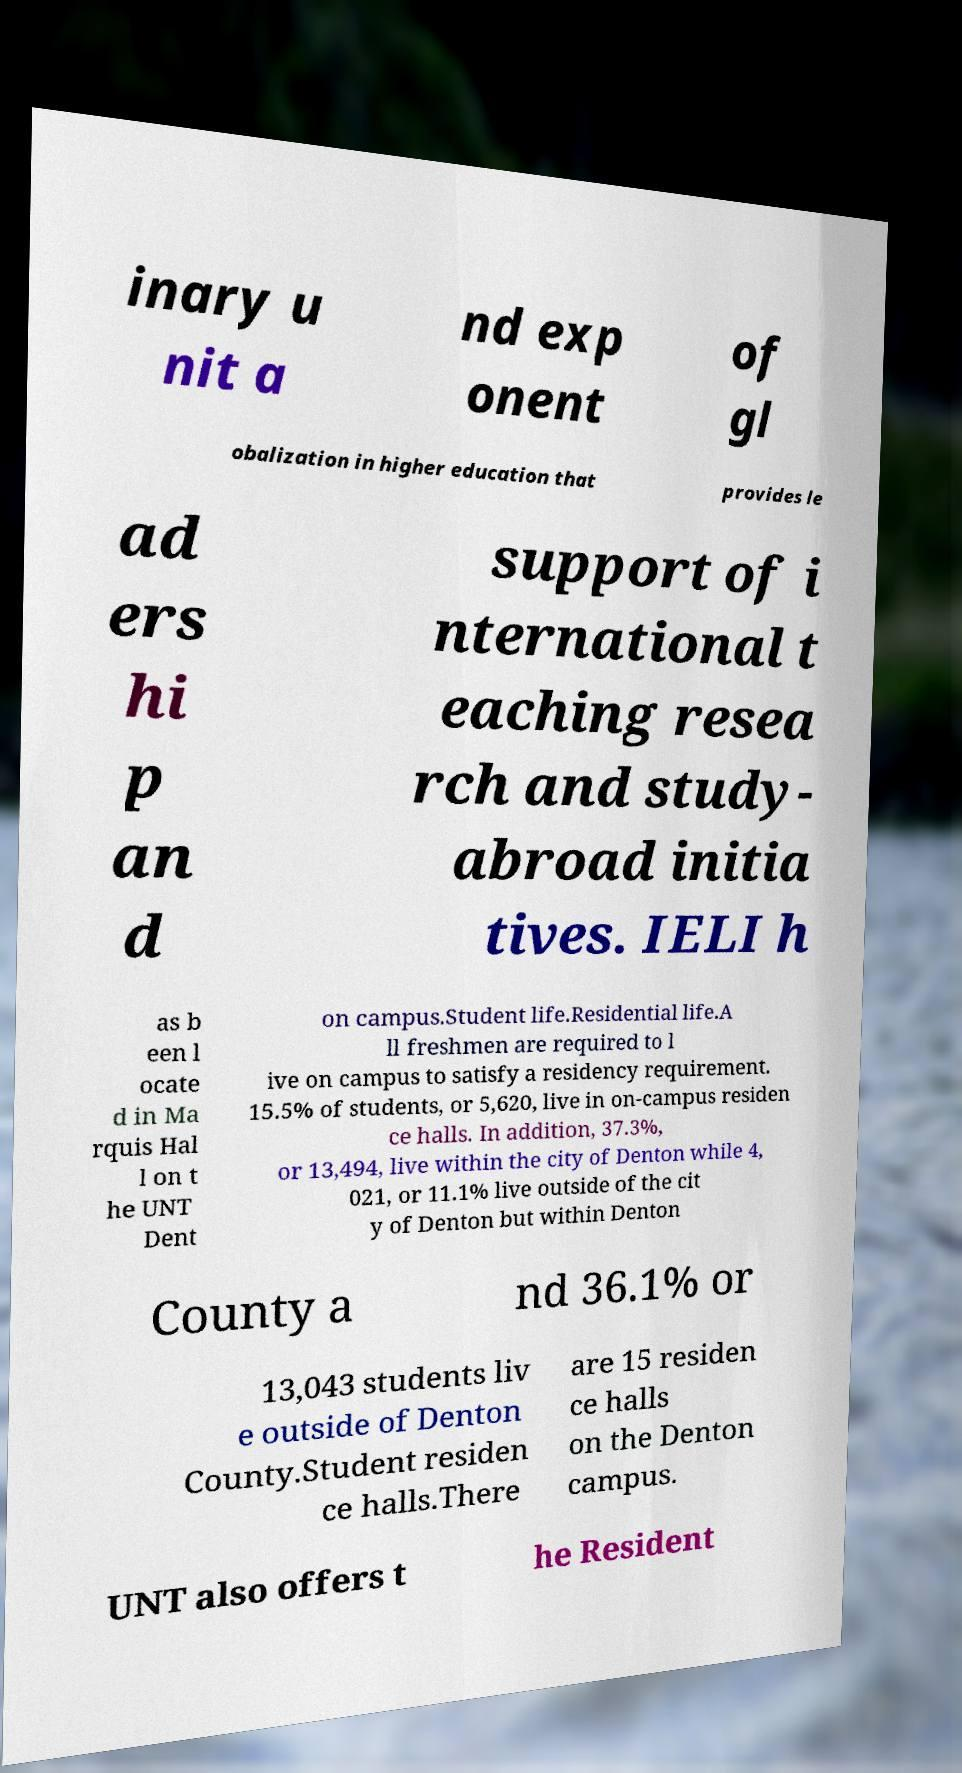For documentation purposes, I need the text within this image transcribed. Could you provide that? inary u nit a nd exp onent of gl obalization in higher education that provides le ad ers hi p an d support of i nternational t eaching resea rch and study- abroad initia tives. IELI h as b een l ocate d in Ma rquis Hal l on t he UNT Dent on campus.Student life.Residential life.A ll freshmen are required to l ive on campus to satisfy a residency requirement. 15.5% of students, or 5,620, live in on-campus residen ce halls. In addition, 37.3%, or 13,494, live within the city of Denton while 4, 021, or 11.1% live outside of the cit y of Denton but within Denton County a nd 36.1% or 13,043 students liv e outside of Denton County.Student residen ce halls.There are 15 residen ce halls on the Denton campus. UNT also offers t he Resident 